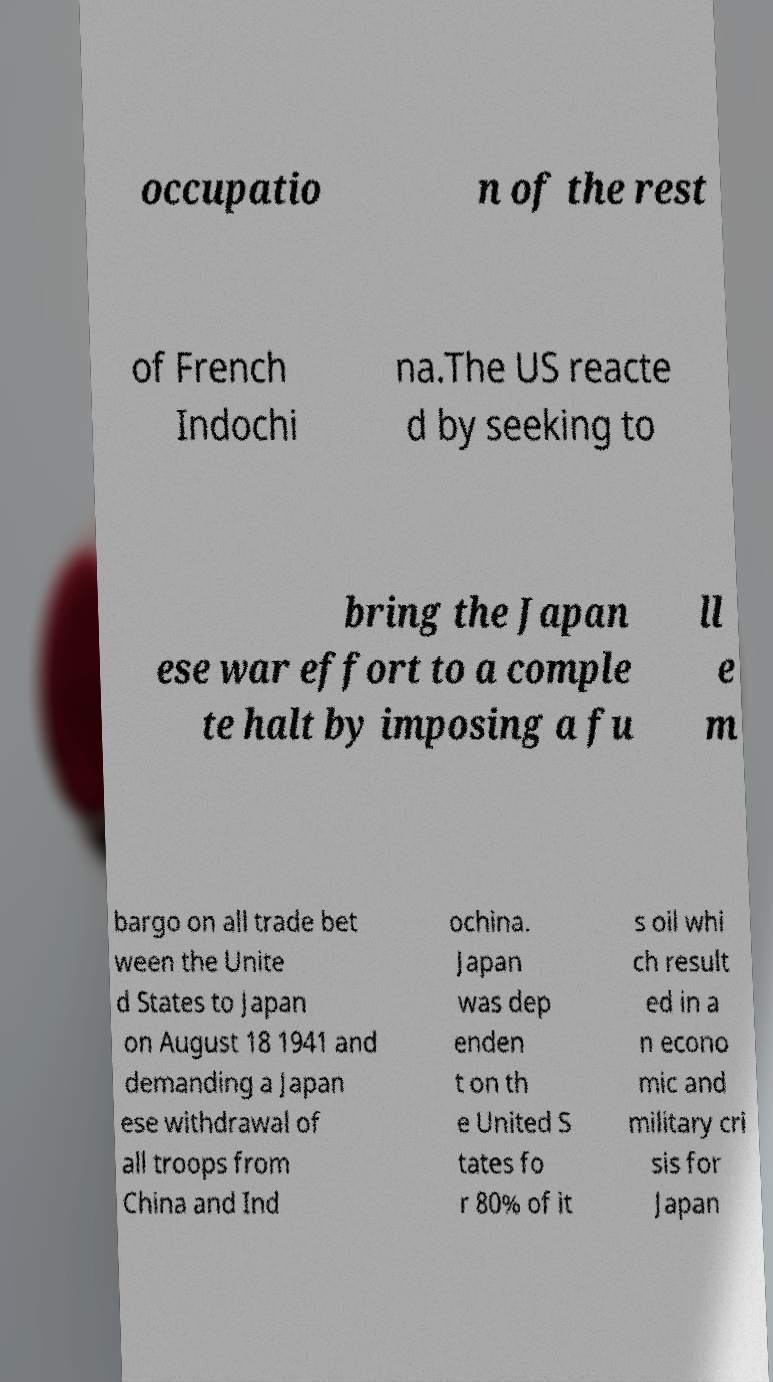Please read and relay the text visible in this image. What does it say? occupatio n of the rest of French Indochi na.The US reacte d by seeking to bring the Japan ese war effort to a comple te halt by imposing a fu ll e m bargo on all trade bet ween the Unite d States to Japan on August 18 1941 and demanding a Japan ese withdrawal of all troops from China and Ind ochina. Japan was dep enden t on th e United S tates fo r 80% of it s oil whi ch result ed in a n econo mic and military cri sis for Japan 